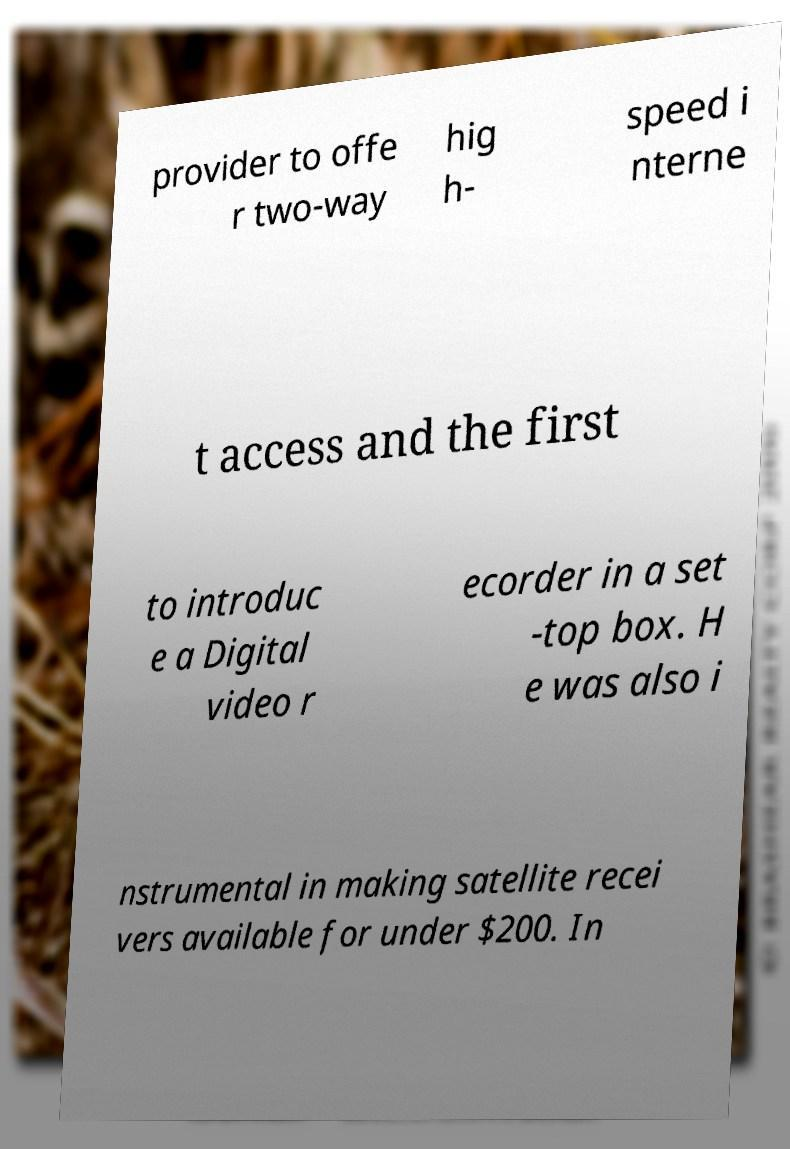Could you extract and type out the text from this image? provider to offe r two-way hig h- speed i nterne t access and the first to introduc e a Digital video r ecorder in a set -top box. H e was also i nstrumental in making satellite recei vers available for under $200. In 